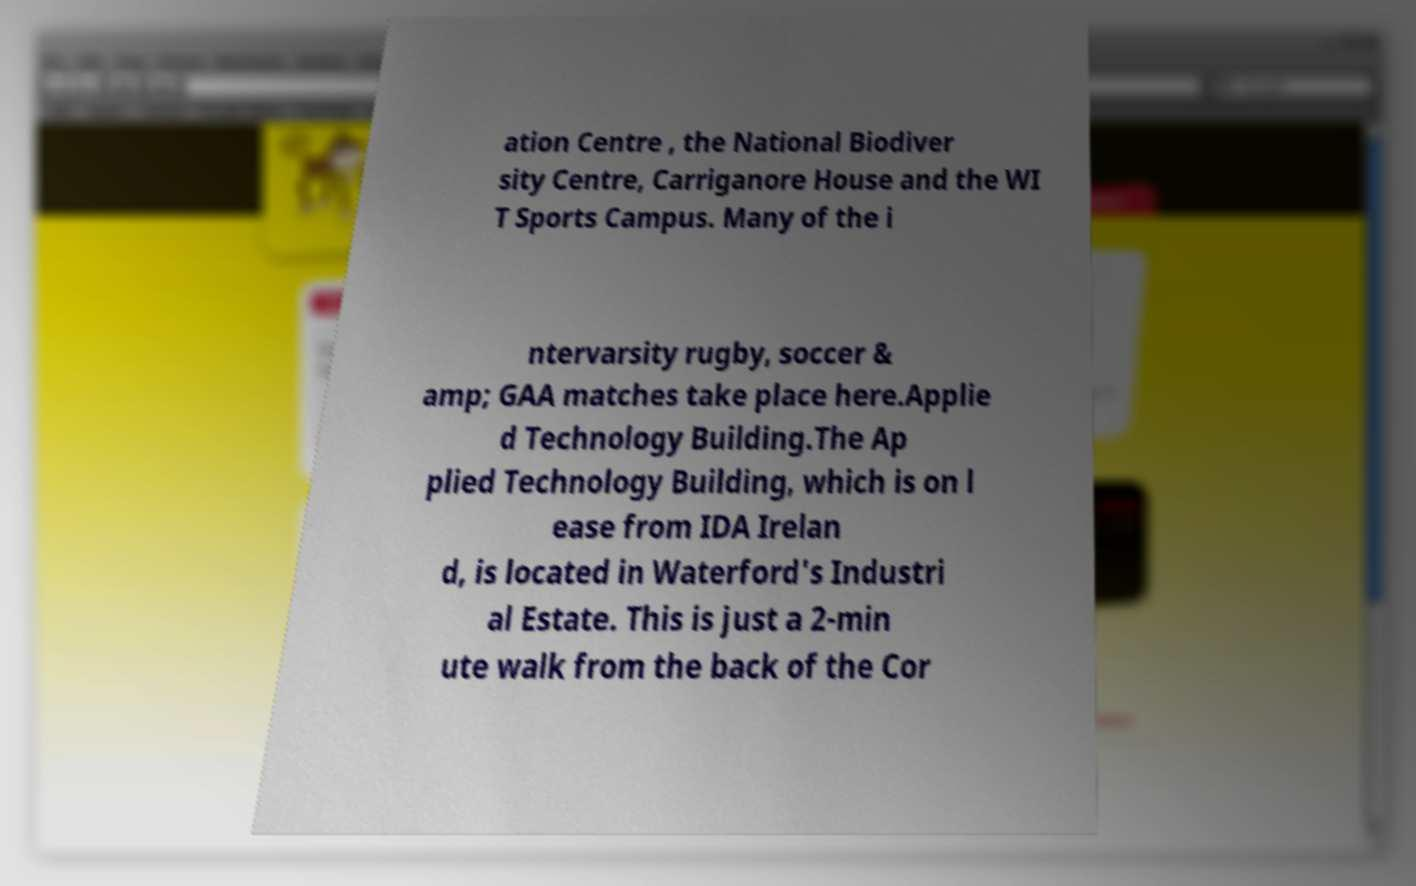There's text embedded in this image that I need extracted. Can you transcribe it verbatim? ation Centre , the National Biodiver sity Centre, Carriganore House and the WI T Sports Campus. Many of the i ntervarsity rugby, soccer & amp; GAA matches take place here.Applie d Technology Building.The Ap plied Technology Building, which is on l ease from IDA Irelan d, is located in Waterford's Industri al Estate. This is just a 2-min ute walk from the back of the Cor 